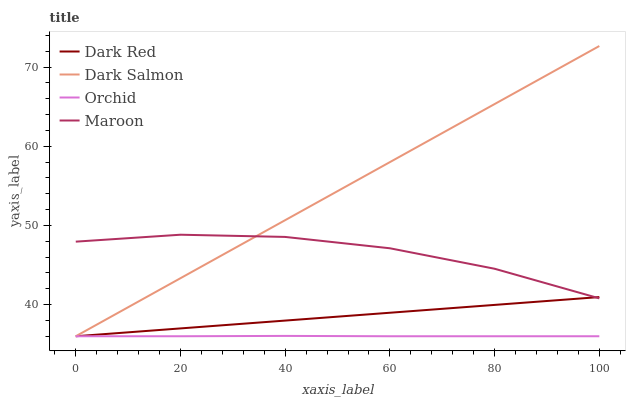Does Orchid have the minimum area under the curve?
Answer yes or no. Yes. Does Dark Salmon have the maximum area under the curve?
Answer yes or no. Yes. Does Maroon have the minimum area under the curve?
Answer yes or no. No. Does Maroon have the maximum area under the curve?
Answer yes or no. No. Is Dark Salmon the smoothest?
Answer yes or no. Yes. Is Maroon the roughest?
Answer yes or no. Yes. Is Maroon the smoothest?
Answer yes or no. No. Is Dark Salmon the roughest?
Answer yes or no. No. Does Dark Red have the lowest value?
Answer yes or no. Yes. Does Maroon have the lowest value?
Answer yes or no. No. Does Dark Salmon have the highest value?
Answer yes or no. Yes. Does Maroon have the highest value?
Answer yes or no. No. Is Orchid less than Maroon?
Answer yes or no. Yes. Is Maroon greater than Orchid?
Answer yes or no. Yes. Does Dark Salmon intersect Orchid?
Answer yes or no. Yes. Is Dark Salmon less than Orchid?
Answer yes or no. No. Is Dark Salmon greater than Orchid?
Answer yes or no. No. Does Orchid intersect Maroon?
Answer yes or no. No. 